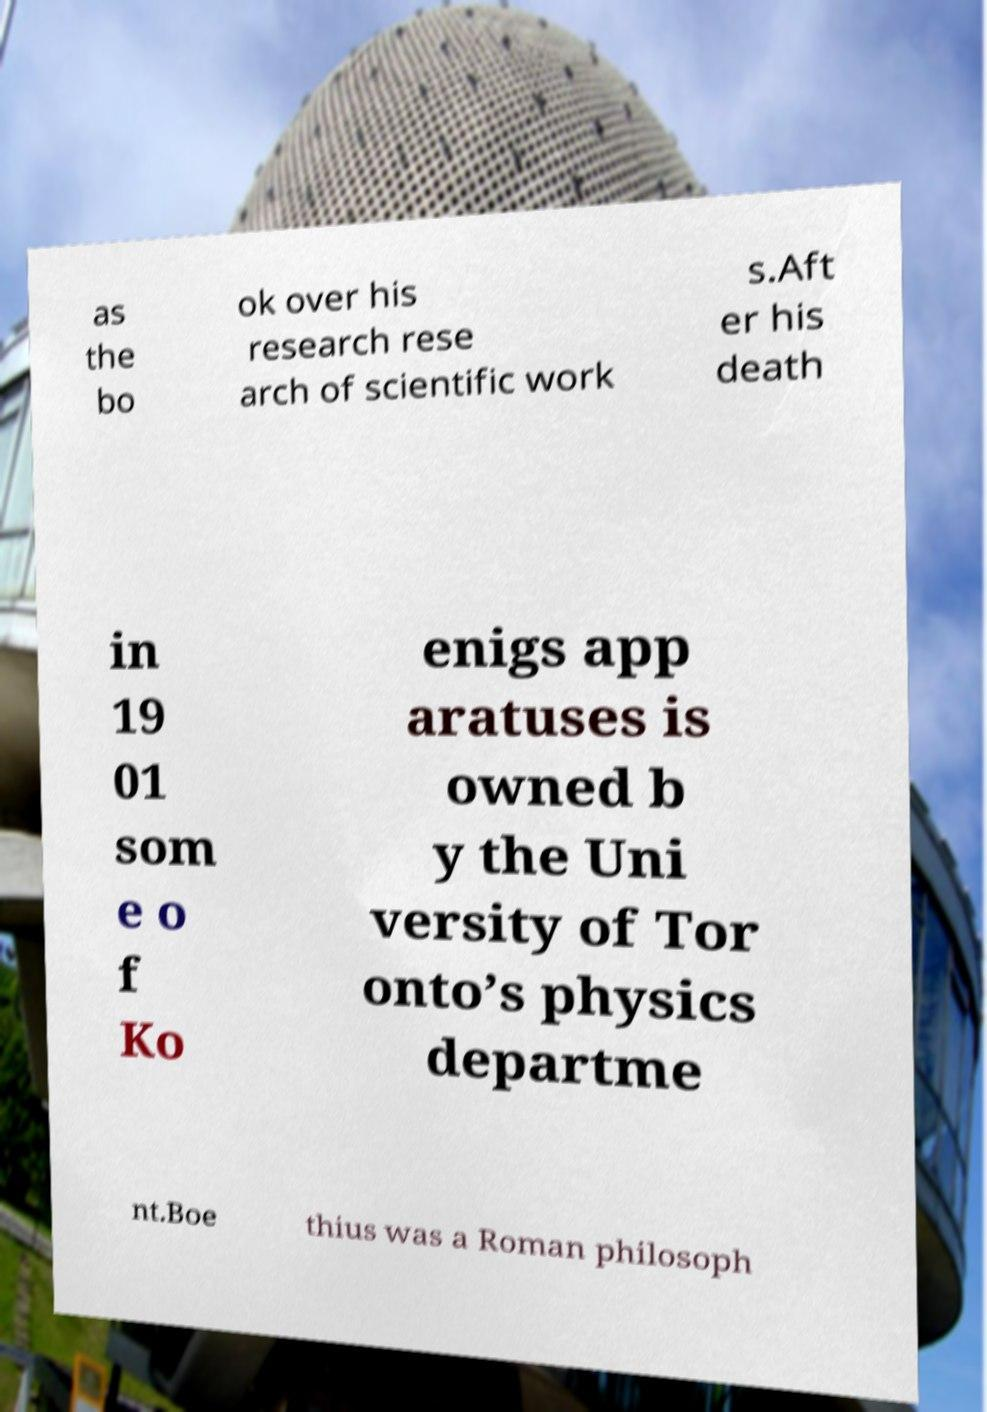Please identify and transcribe the text found in this image. as the bo ok over his research rese arch of scientific work s.Aft er his death in 19 01 som e o f Ko enigs app aratuses is owned b y the Uni versity of Tor onto’s physics departme nt.Boe thius was a Roman philosoph 